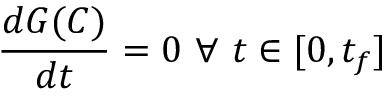<formula> <loc_0><loc_0><loc_500><loc_500>\frac { d G ( C ) } { d t } = 0 \ \forall \ t \in [ 0 , t _ { f } ]</formula> 